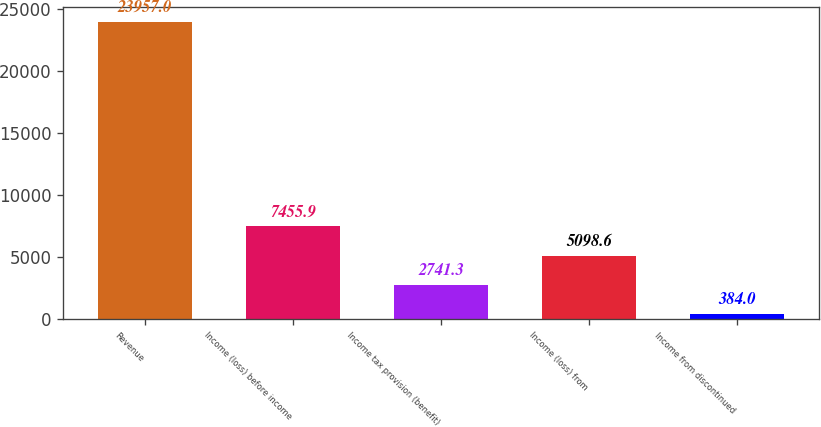Convert chart to OTSL. <chart><loc_0><loc_0><loc_500><loc_500><bar_chart><fcel>Revenue<fcel>Income (loss) before income<fcel>Income tax provision (benefit)<fcel>Income (loss) from<fcel>Income from discontinued<nl><fcel>23957<fcel>7455.9<fcel>2741.3<fcel>5098.6<fcel>384<nl></chart> 